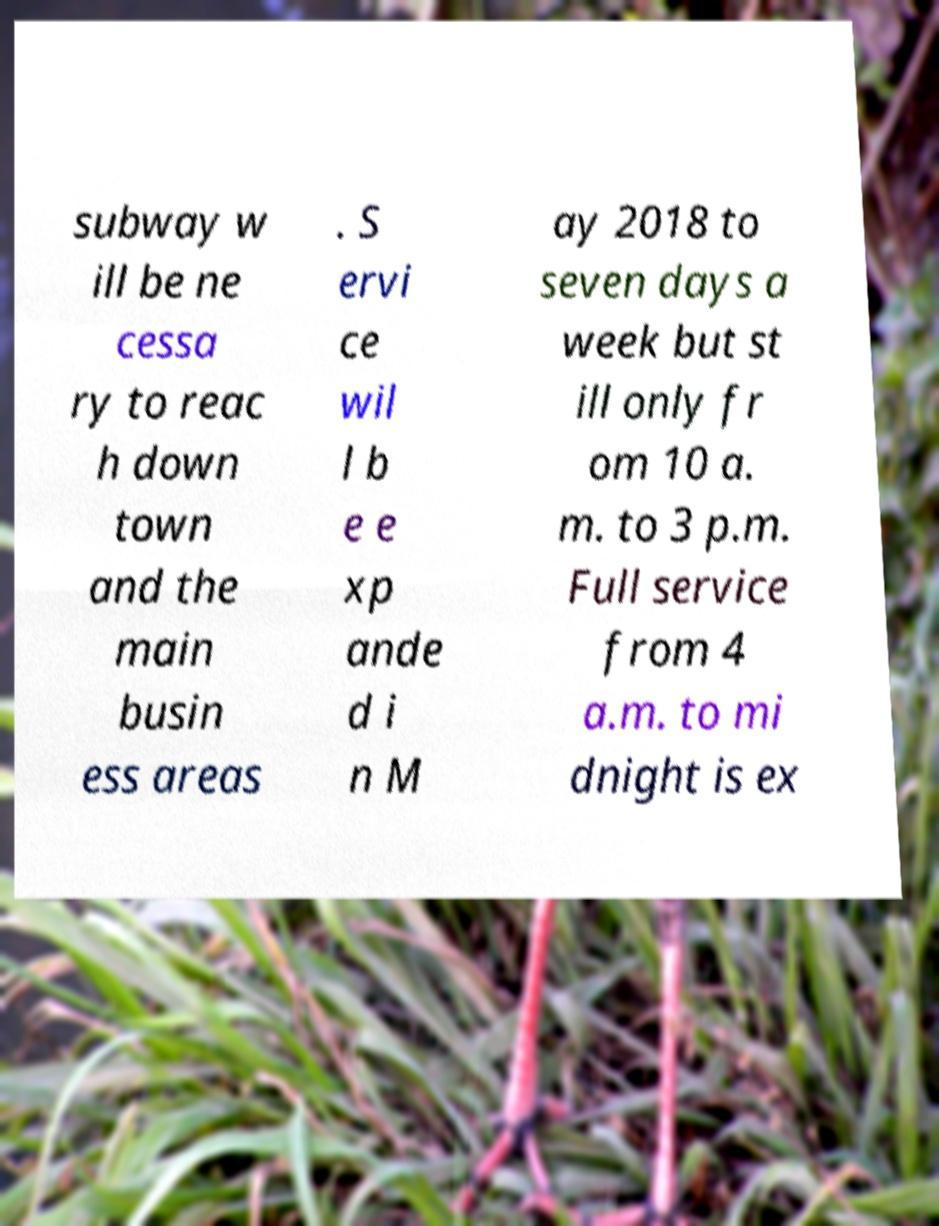Please read and relay the text visible in this image. What does it say? subway w ill be ne cessa ry to reac h down town and the main busin ess areas . S ervi ce wil l b e e xp ande d i n M ay 2018 to seven days a week but st ill only fr om 10 a. m. to 3 p.m. Full service from 4 a.m. to mi dnight is ex 